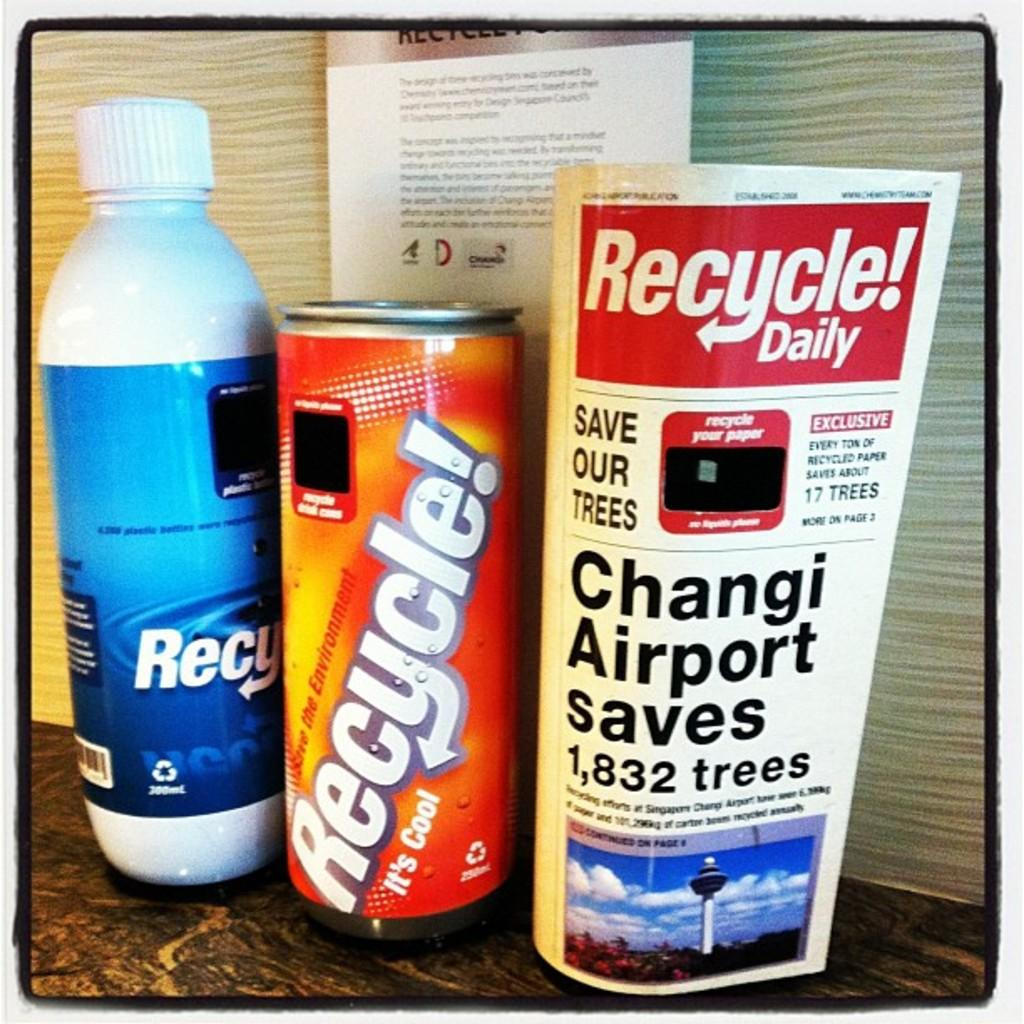<image>
Relay a brief, clear account of the picture shown. A bottle, can, and a pamphlet encourage people to recycle. 